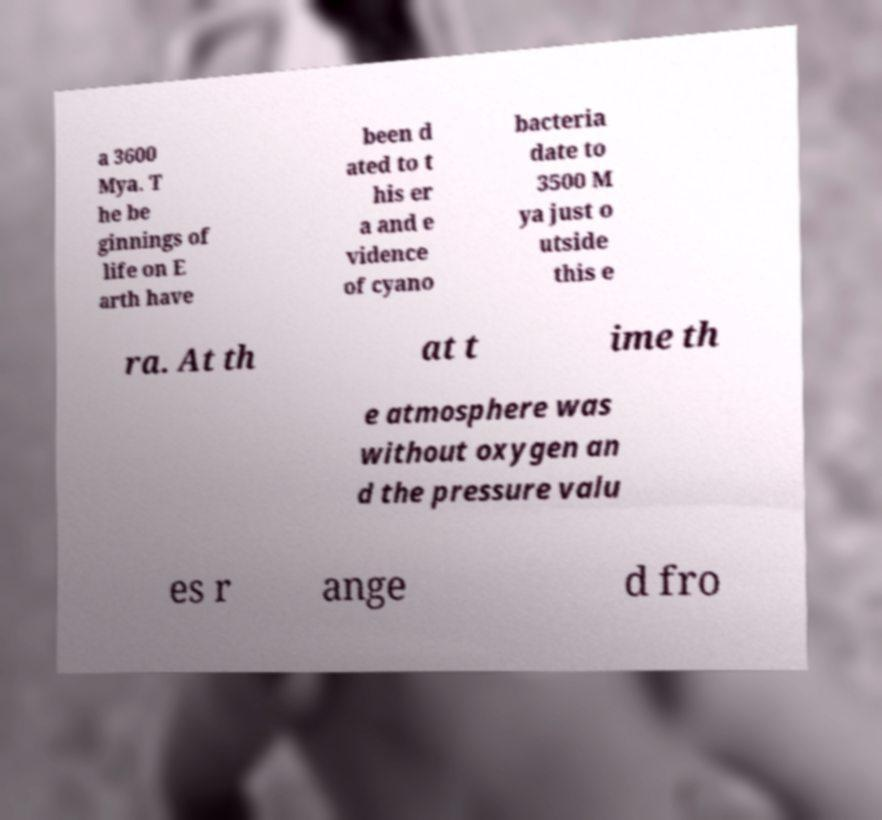Can you accurately transcribe the text from the provided image for me? a 3600 Mya. T he be ginnings of life on E arth have been d ated to t his er a and e vidence of cyano bacteria date to 3500 M ya just o utside this e ra. At th at t ime th e atmosphere was without oxygen an d the pressure valu es r ange d fro 